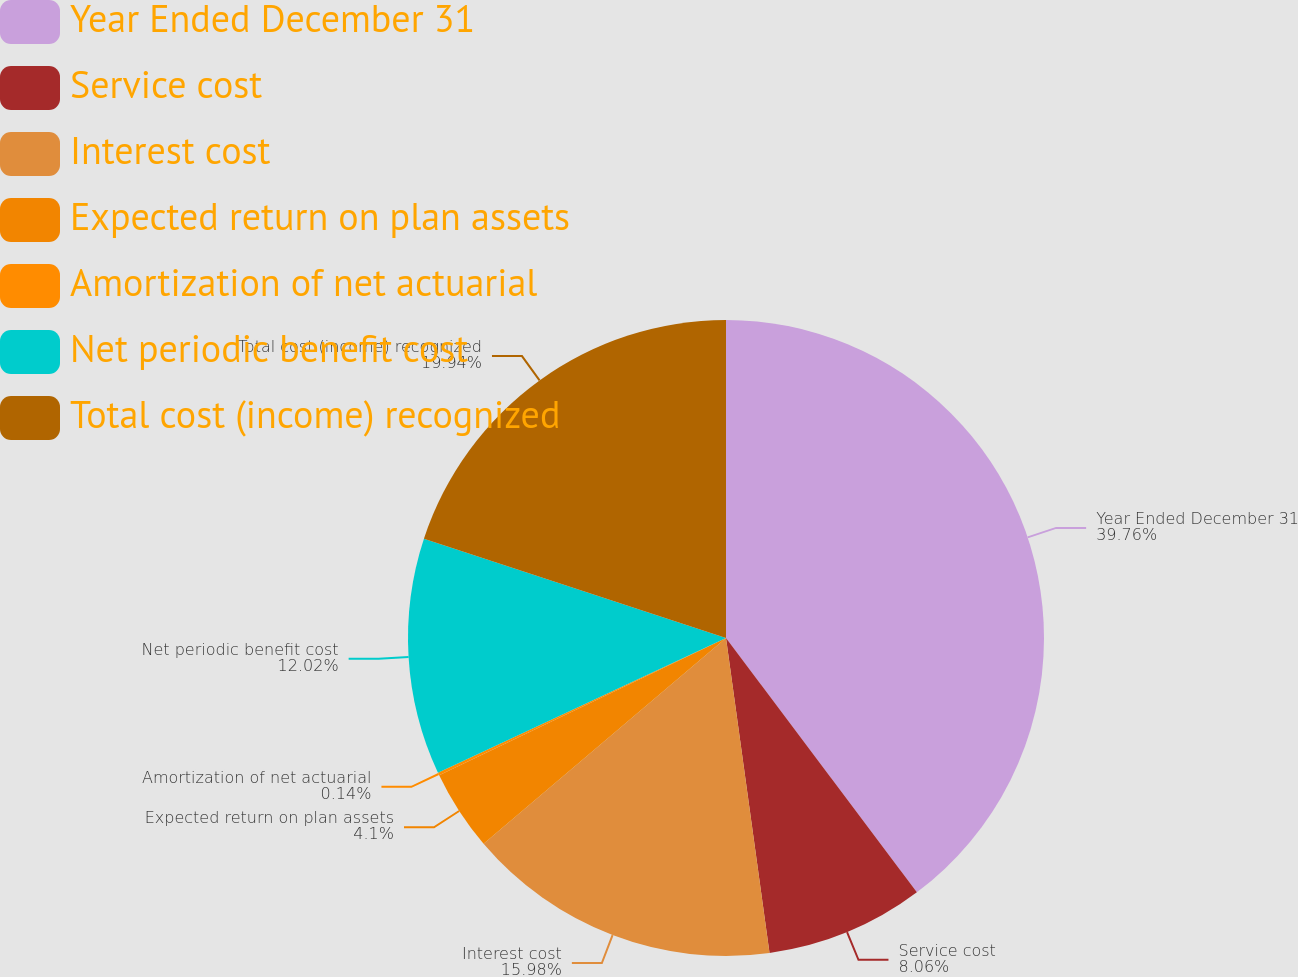<chart> <loc_0><loc_0><loc_500><loc_500><pie_chart><fcel>Year Ended December 31<fcel>Service cost<fcel>Interest cost<fcel>Expected return on plan assets<fcel>Amortization of net actuarial<fcel>Net periodic benefit cost<fcel>Total cost (income) recognized<nl><fcel>39.75%<fcel>8.06%<fcel>15.98%<fcel>4.1%<fcel>0.14%<fcel>12.02%<fcel>19.94%<nl></chart> 